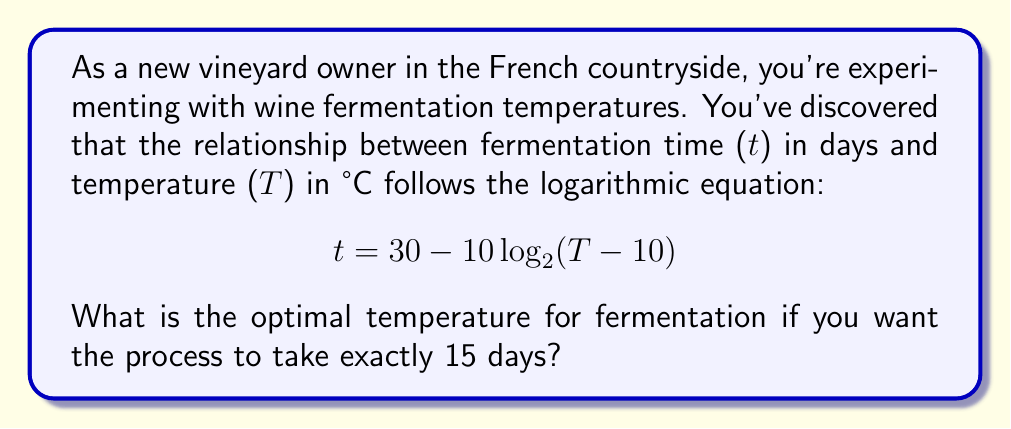What is the answer to this math problem? Let's approach this step-by-step:

1) We're given the equation: $t = 30 - 10\log_2(T-10)$

2) We want to find T when t = 15 days. Let's substitute this:

   $15 = 30 - 10\log_2(T-10)$

3) Subtract 30 from both sides:

   $-15 = -10\log_2(T-10)$

4) Divide both sides by -10:

   $1.5 = \log_2(T-10)$

5) To solve for T, we need to apply the inverse function (exponentiation) to both sides:

   $2^{1.5} = T-10$

6) Calculate $2^{1.5}$:

   $2^{1.5} \approx 2.8284$

7) Add 10 to both sides:

   $T \approx 2.8284 + 10 = 12.8284$

8) Round to one decimal place for practicality in temperature control:

   $T \approx 12.8°C$
Answer: $12.8°C$ 